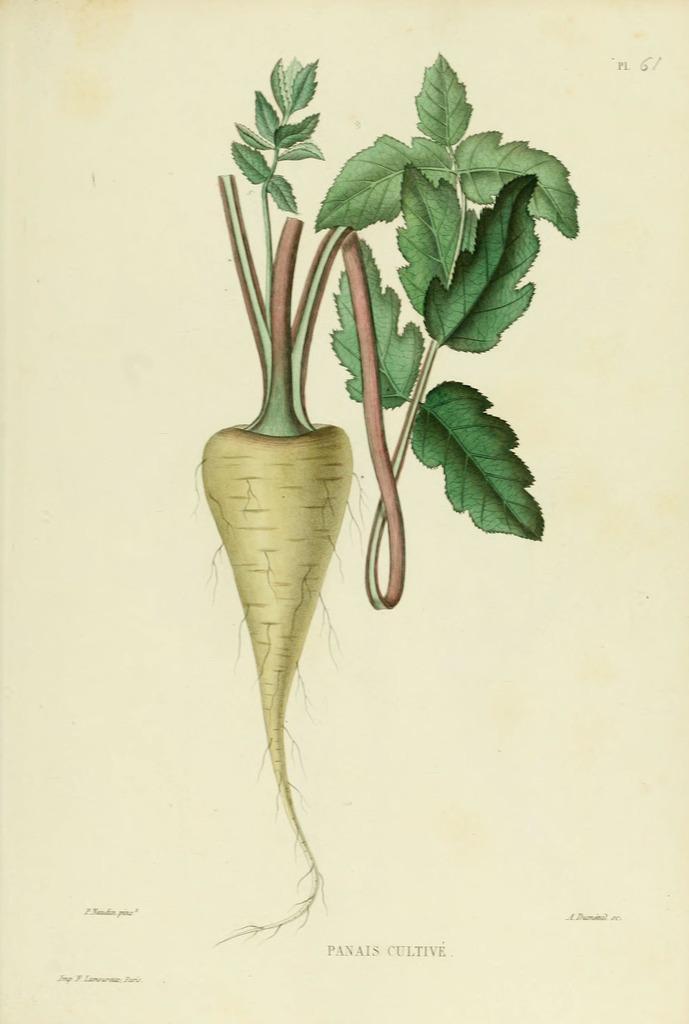In one or two sentences, can you explain what this image depicts? In the center of the image there is a painting of a vegetable plant. 